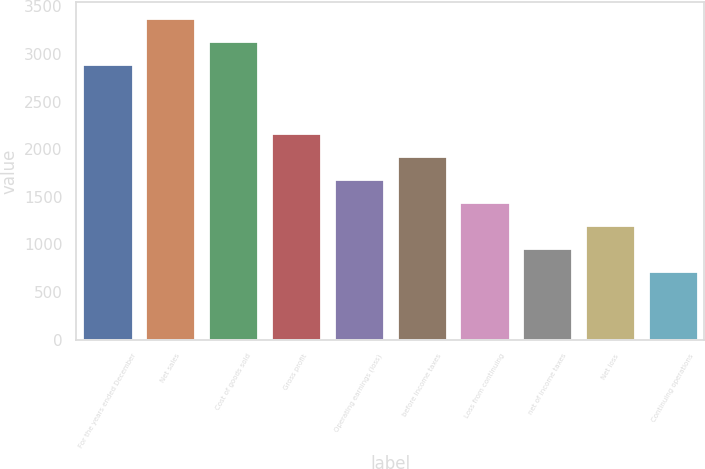Convert chart. <chart><loc_0><loc_0><loc_500><loc_500><bar_chart><fcel>For the years ended December<fcel>Net sales<fcel>Cost of goods sold<fcel>Gross profit<fcel>Operating earnings (loss)<fcel>before income taxes<fcel>Loss from continuing<fcel>net of income taxes<fcel>Net loss<fcel>Continuing operations<nl><fcel>2893.45<fcel>3375.69<fcel>3134.57<fcel>2170.09<fcel>1687.85<fcel>1928.97<fcel>1446.73<fcel>964.49<fcel>1205.61<fcel>723.37<nl></chart> 